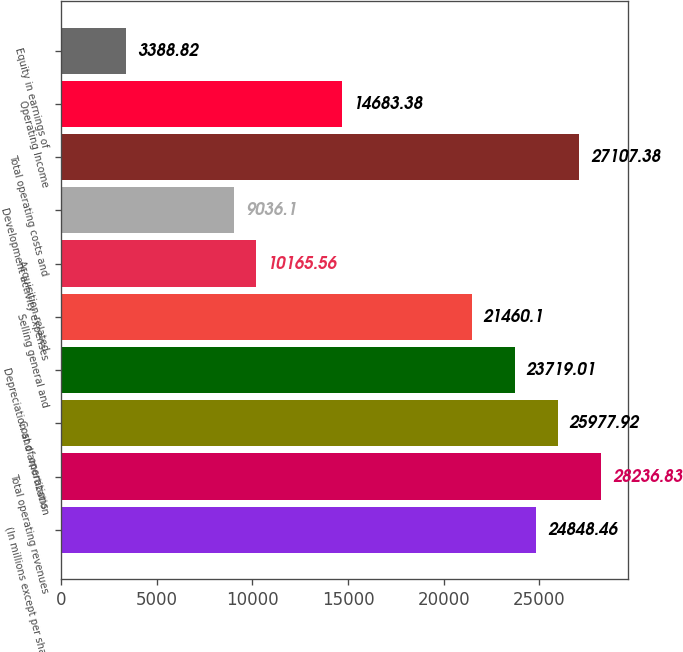<chart> <loc_0><loc_0><loc_500><loc_500><bar_chart><fcel>(In millions except per share<fcel>Total operating revenues<fcel>Cost of operations<fcel>Depreciation and amortization<fcel>Selling general and<fcel>Acquisition-related<fcel>Development activity expenses<fcel>Total operating costs and<fcel>Operating Income<fcel>Equity in earnings of<nl><fcel>24848.5<fcel>28236.8<fcel>25977.9<fcel>23719<fcel>21460.1<fcel>10165.6<fcel>9036.1<fcel>27107.4<fcel>14683.4<fcel>3388.82<nl></chart> 